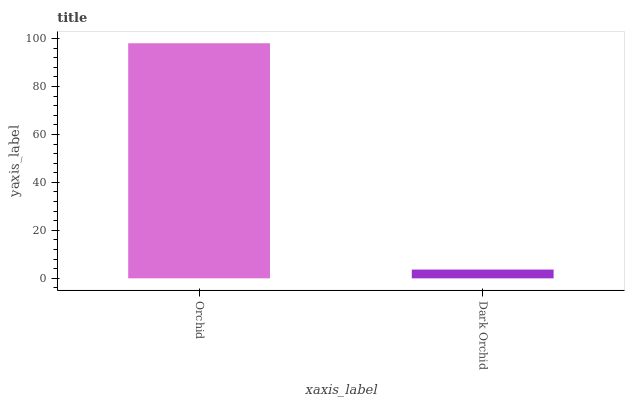Is Dark Orchid the minimum?
Answer yes or no. Yes. Is Orchid the maximum?
Answer yes or no. Yes. Is Dark Orchid the maximum?
Answer yes or no. No. Is Orchid greater than Dark Orchid?
Answer yes or no. Yes. Is Dark Orchid less than Orchid?
Answer yes or no. Yes. Is Dark Orchid greater than Orchid?
Answer yes or no. No. Is Orchid less than Dark Orchid?
Answer yes or no. No. Is Orchid the high median?
Answer yes or no. Yes. Is Dark Orchid the low median?
Answer yes or no. Yes. Is Dark Orchid the high median?
Answer yes or no. No. Is Orchid the low median?
Answer yes or no. No. 